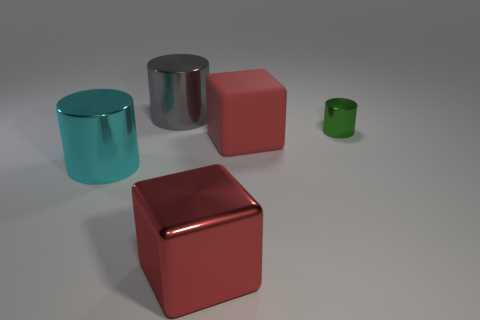Subtract all gray metallic cylinders. How many cylinders are left? 2 Add 5 purple matte cubes. How many objects exist? 10 Subtract all cyan cylinders. How many cylinders are left? 2 Subtract all cubes. How many objects are left? 3 Subtract 0 purple blocks. How many objects are left? 5 Subtract all green cylinders. Subtract all red balls. How many cylinders are left? 2 Subtract all small shiny objects. Subtract all big red matte cubes. How many objects are left? 3 Add 1 big red metallic cubes. How many big red metallic cubes are left? 2 Add 5 tiny red metallic cubes. How many tiny red metallic cubes exist? 5 